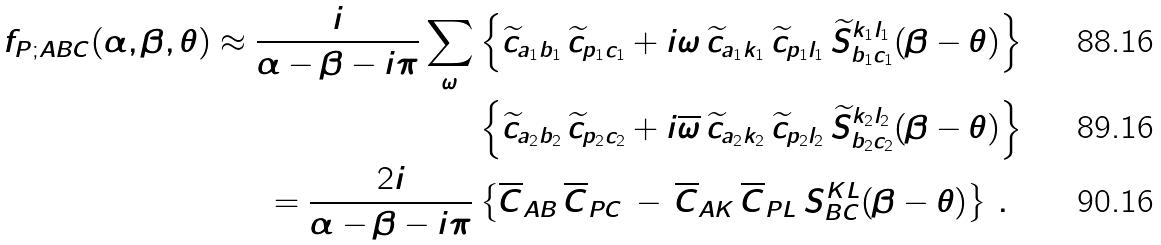Convert formula to latex. <formula><loc_0><loc_0><loc_500><loc_500>f _ { P ; A B C } ( \alpha , \beta , \theta ) \approx \frac { i } { \alpha - \beta - i \pi } \sum _ { \omega } & \left \{ \widetilde { c } _ { a _ { 1 } b _ { 1 } } \, \widetilde { c } _ { p _ { 1 } c _ { 1 } } + i \omega \, \widetilde { c } _ { a _ { 1 } k _ { 1 } } \, \widetilde { c } _ { p _ { 1 } l _ { 1 } } \, \widetilde { S } ^ { k _ { 1 } l _ { 1 } } _ { b _ { 1 } c _ { 1 } } ( \beta - \theta ) \right \} \\ & \left \{ \widetilde { c } _ { a _ { 2 } b _ { 2 } } \, \widetilde { c } _ { p _ { 2 } c _ { 2 } } + i \overline { \omega } \, \widetilde { c } _ { a _ { 2 } k _ { 2 } } \, \widetilde { c } _ { p _ { 2 } l _ { 2 } } \, \widetilde { S } ^ { k _ { 2 } l _ { 2 } } _ { b _ { 2 } c _ { 2 } } ( \beta - \theta ) \right \} \\ = \frac { 2 i } { \alpha - \beta - i \pi } & \left \{ \overline { C } _ { A B } \, \overline { C } _ { P C } \, - \, \overline { C } _ { A K } \, \overline { C } _ { P L } \, S ^ { K L } _ { B C } ( \beta - \theta ) \right \} \, .</formula> 